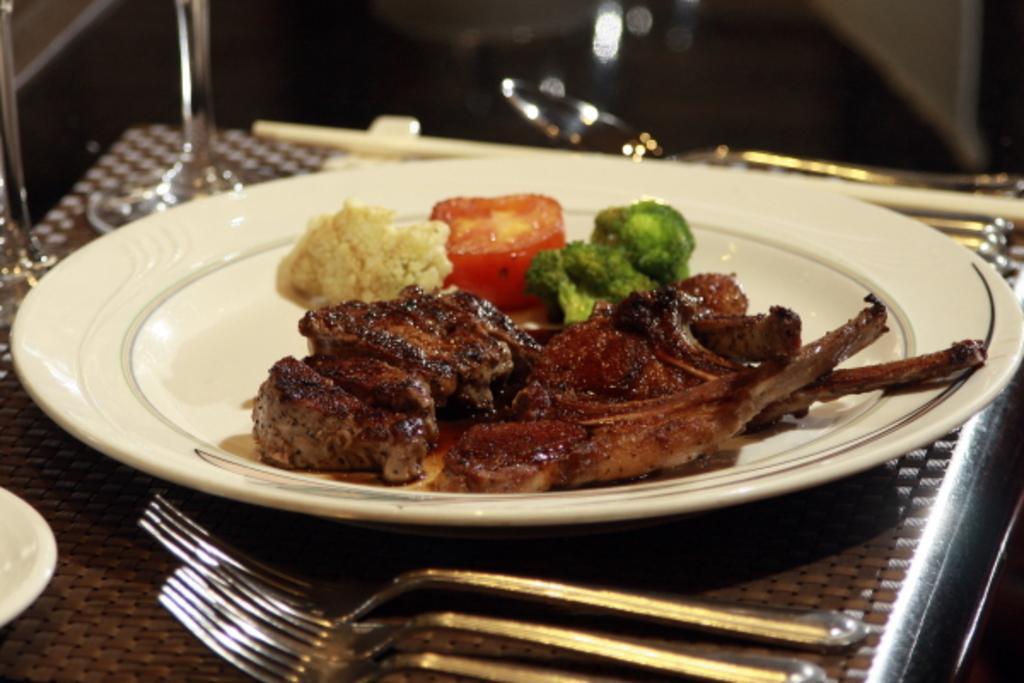Please provide a concise description of this image. In the image we can see there is a plate kept on the table and there is a meat on it. There are forks kept on the table. 